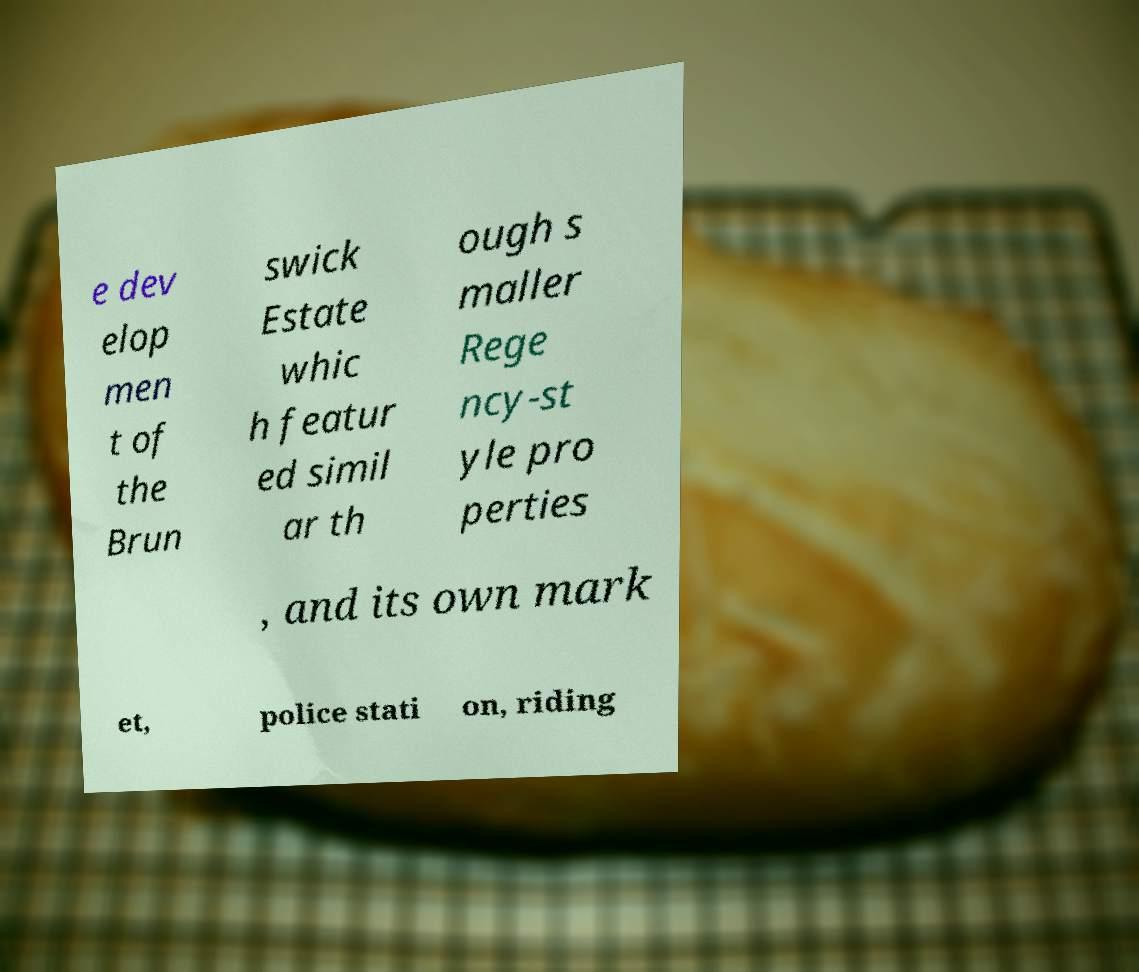Please identify and transcribe the text found in this image. e dev elop men t of the Brun swick Estate whic h featur ed simil ar th ough s maller Rege ncy-st yle pro perties , and its own mark et, police stati on, riding 